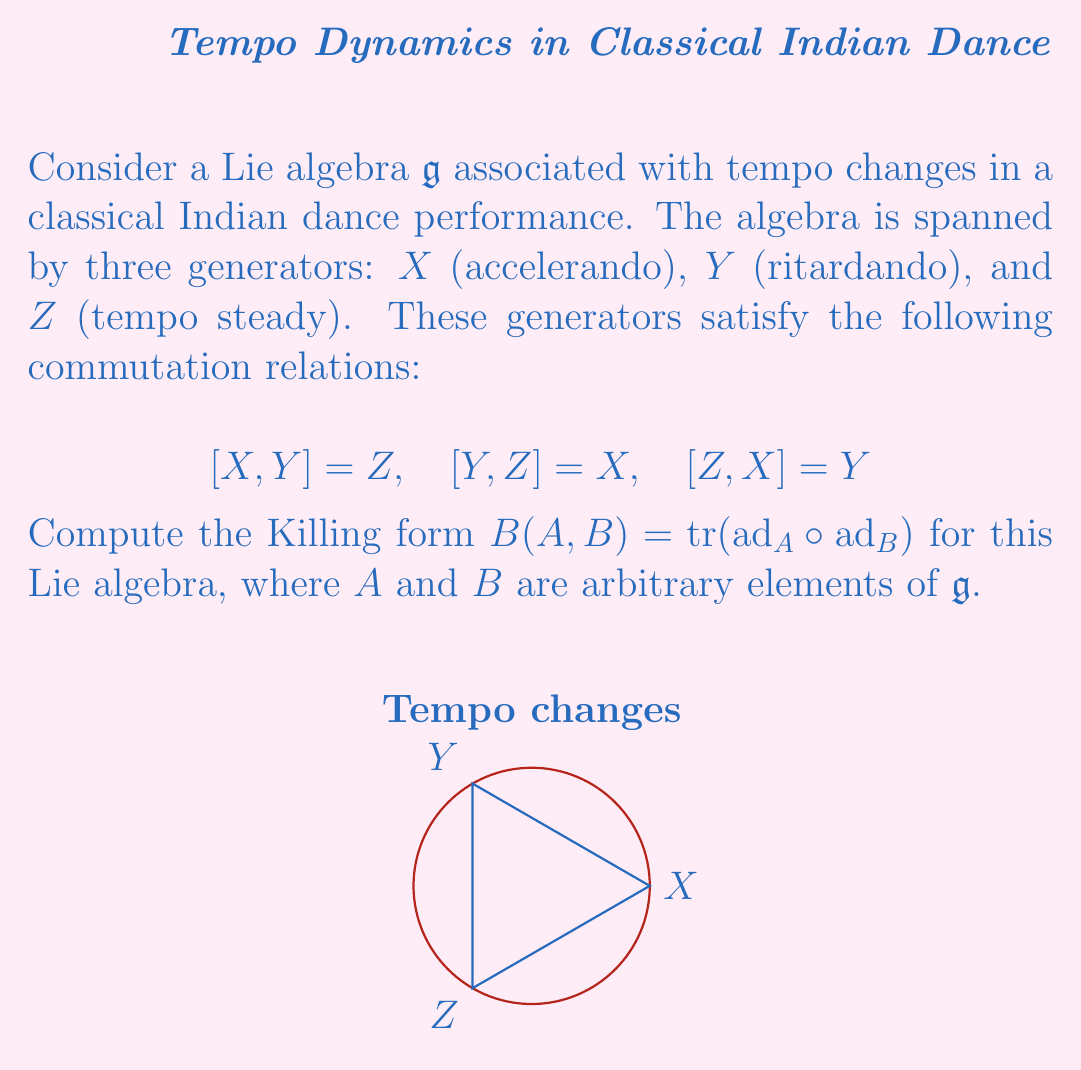Solve this math problem. Let's approach this step-by-step:

1) First, we need to find the adjoint representations of $X$, $Y$, and $Z$. Using the given commutation relations:

   $\text{ad}_X = \begin{pmatrix} 0 & 0 & -1 \\ 0 & 0 & 1 \\ 1 & -1 & 0 \end{pmatrix}$

   $\text{ad}_Y = \begin{pmatrix} 0 & 0 & 1 \\ 0 & 0 & -1 \\ -1 & 1 & 0 \end{pmatrix}$

   $\text{ad}_Z = \begin{pmatrix} 0 & -1 & 0 \\ 1 & 0 & 0 \\ 0 & 0 & 0 \end{pmatrix}$

2) Now, let $A = aX + bY + cZ$ and $B = dX + eY + fZ$ be arbitrary elements of $\mathfrak{g}$.

3) We need to compute $\text{ad}_A \circ \text{ad}_B$:

   $\text{ad}_A = a\text{ad}_X + b\text{ad}_Y + c\text{ad}_Z$
   $\text{ad}_B = d\text{ad}_X + e\text{ad}_Y + f\text{ad}_Z$

4) Multiplying these matrices and taking the trace:

   $\text{tr}(\text{ad}_A \circ \text{ad}_B) = 2(ad + be + cf)$

5) Therefore, the Killing form is:

   $B(A,B) = 2(ad + be + cf)$

This is a symmetric bilinear form on $\mathfrak{g}$.
Answer: $B(A,B) = 2(ad + be + cf)$ 